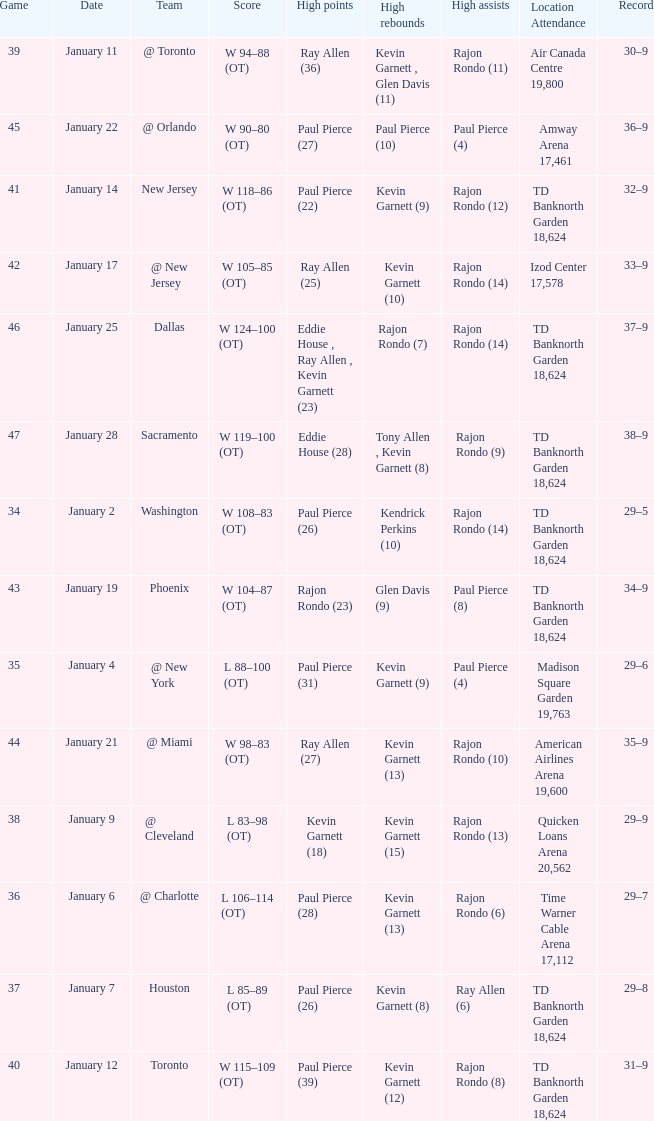Who had the high rebound total on january 6? Kevin Garnett (13). 